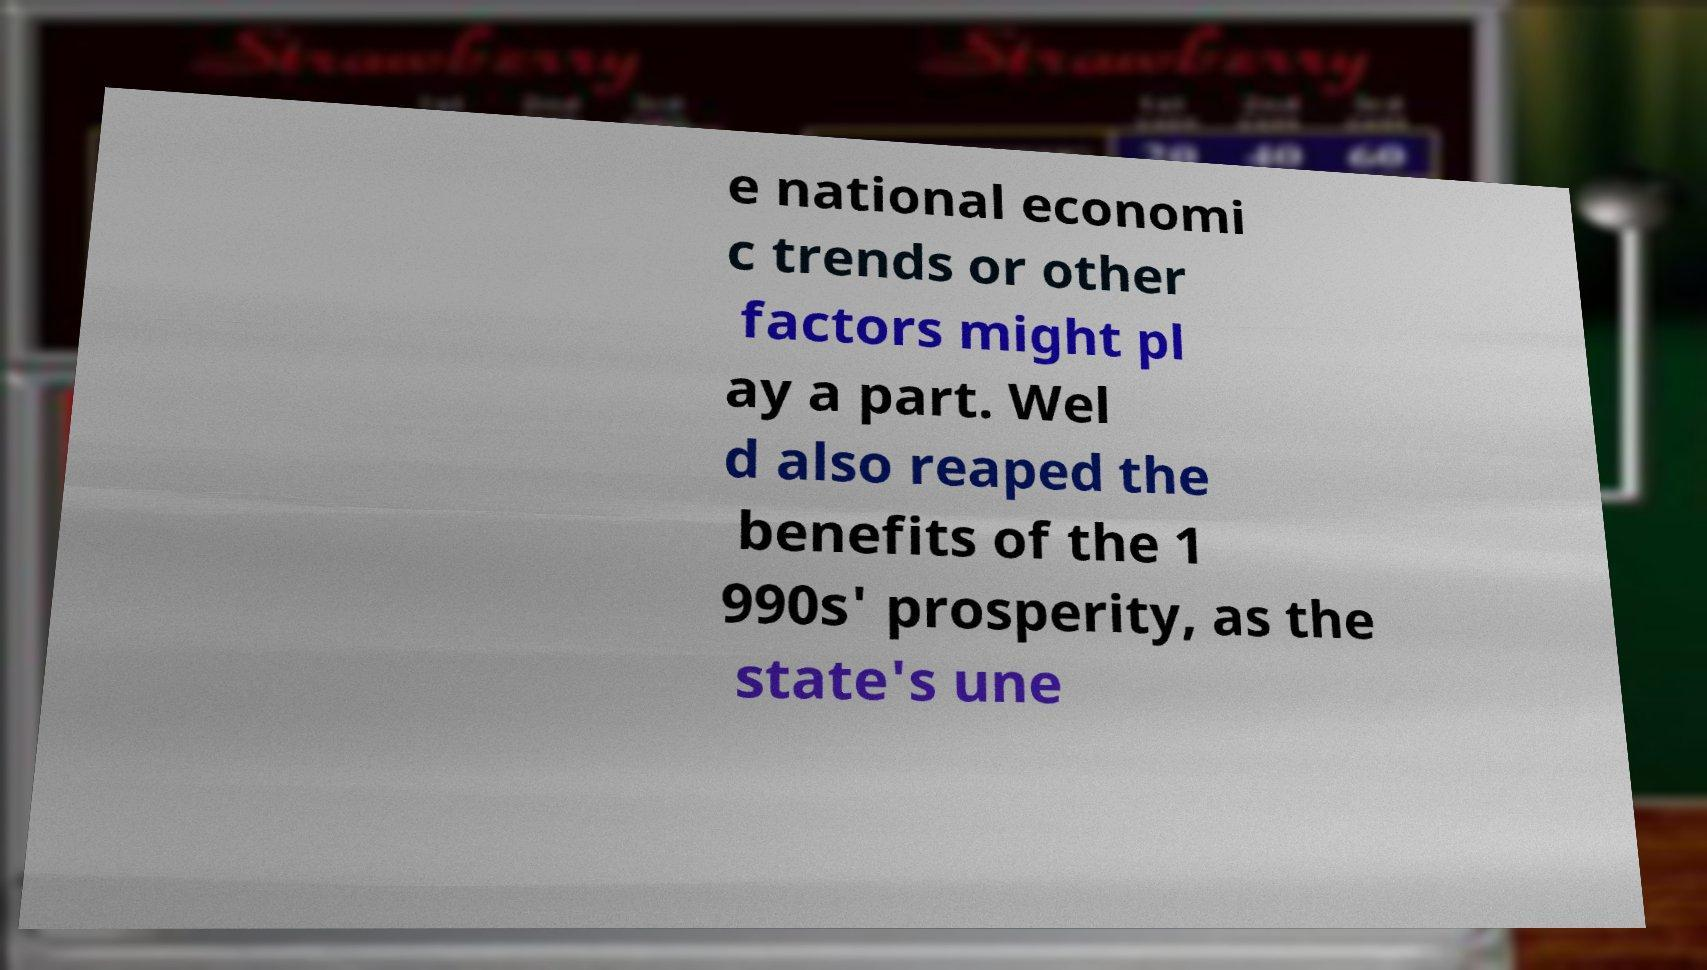Could you extract and type out the text from this image? e national economi c trends or other factors might pl ay a part. Wel d also reaped the benefits of the 1 990s' prosperity, as the state's une 